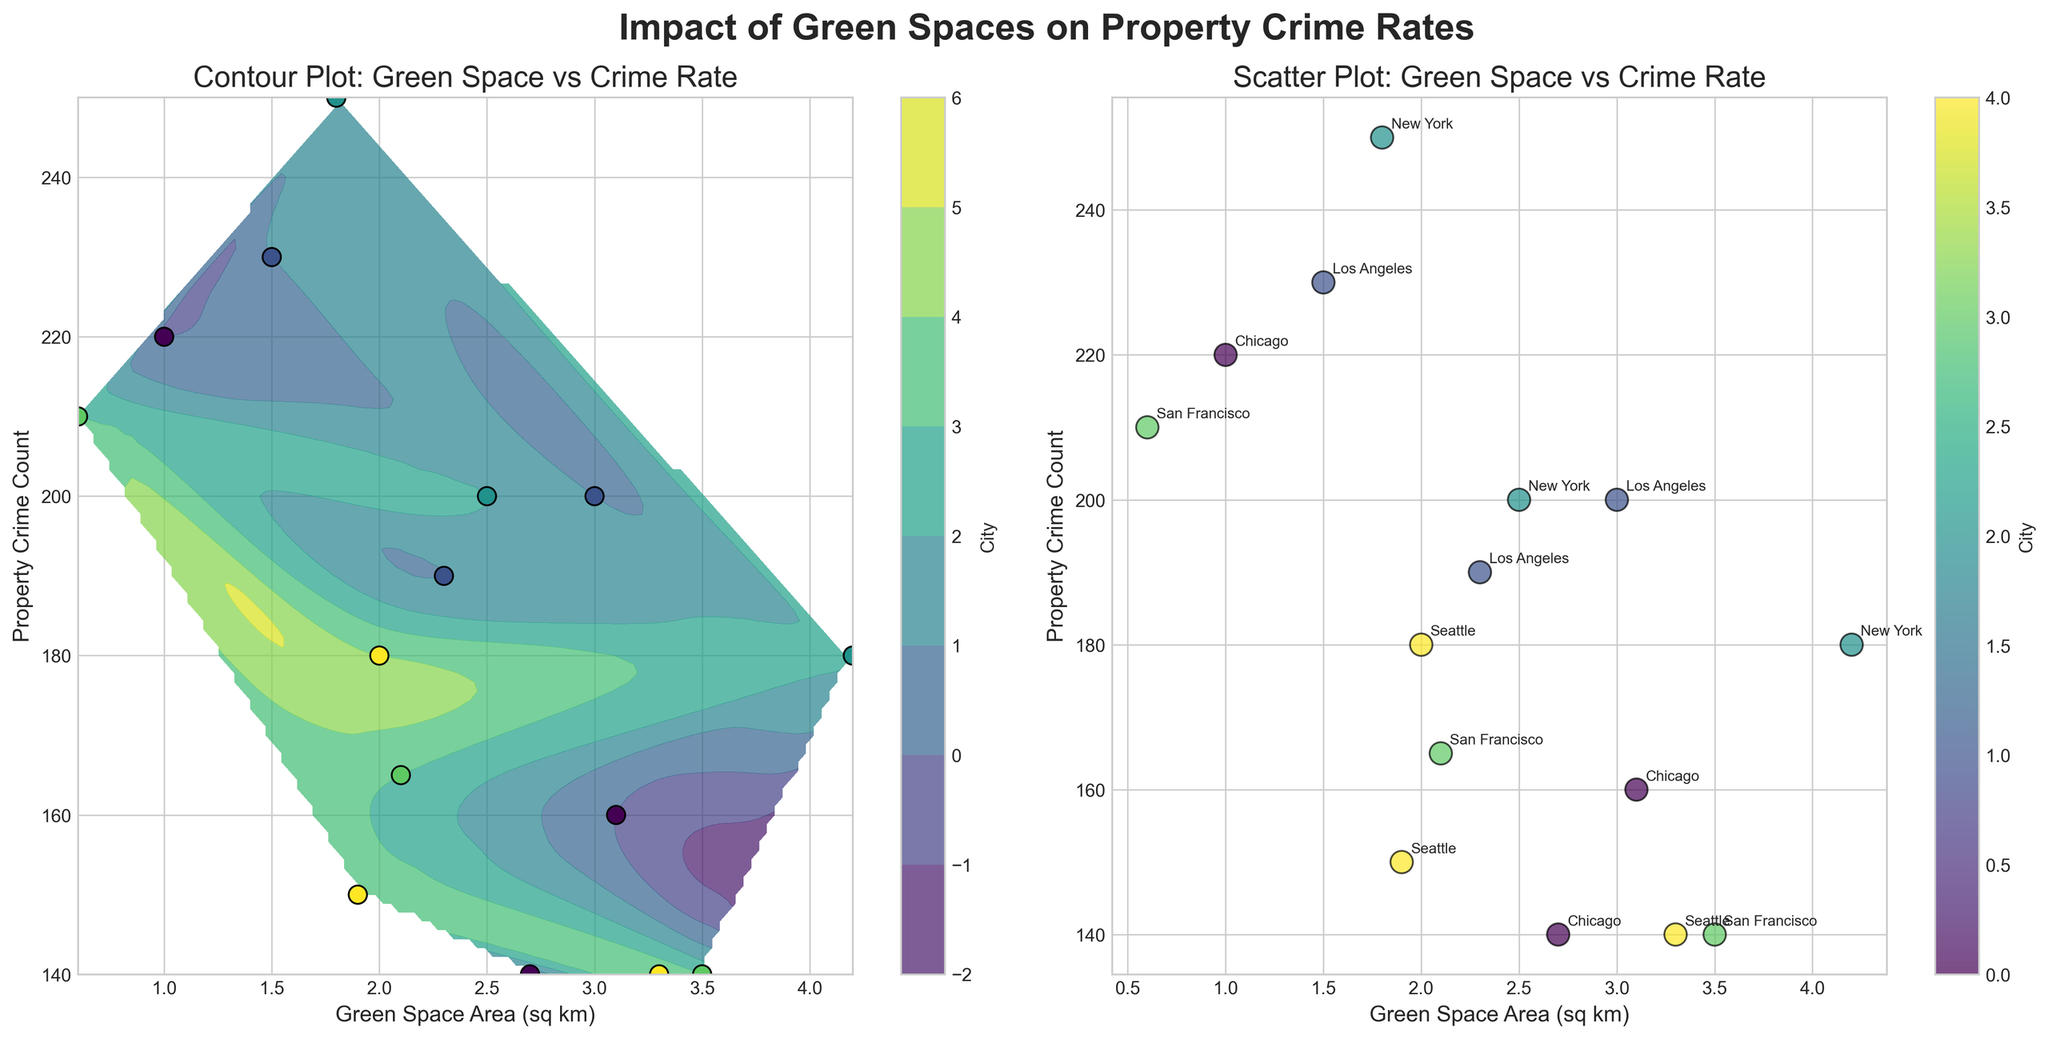What is the title of the figure? The title of the figure is shown at the top of the figure in bold text. It gives an overall description of the visualized data.
Answer: Impact of Green Spaces on Property Crime Rates Which city has the highest property crime count in the scatter plot? By examining the scatter plot, find the data point with the highest position on the Property Crime Count axis.
Answer: New York (Manhattan) What is the range of Green Space Area (sq km) shown on the x-axis? Look at the start and end points of the x-axis in both subplots to determine the range of Green Space Area.
Answer: 0.6 to 4.2 sq km How many neighborhoods have property crime counts below 150? Count the number of data points below the 150 mark on the Property Crime Count axis in both subplots.
Answer: 4 neighborhoods Which city appears to have the least green space area yet high property crime rate? Identify the city with the lowest values on the Green Space Area axis and high values on the Property Crime Count axis in the scatter plot.
Answer: San Francisco (Chinatown) Are there more data points in the lower or higher ranges of green space areas? Compare the density of data points on the x-axis across the scatter plot to see whether they are more frequent in the lower or higher ranges.
Answer: Lower ranges In which subplot are the city names annotated on the data points? Look at both subplots and identify which one has text labels next to the data points, indicating the names of the cities.
Answer: Scatter Plot How do property crime counts generally change as green space area increases? Examine the overall trend of data points in the scatter plot to infer the relationship between green space area and crime counts.
Answer: Generally decreases What colors are used to represent cities in the contour plot? Observe the colorbar next to the contour plot to determine the range of colors used to represent different cities.
Answer: Shades of green and purple What is the impact of green space on property crime rates in Chicago neighborhoods? Identify the data points representing Chicago neighborhoods in both subplots and analyze the trend between green space area and property crime counts.
Answer: Generally lower crime rates with more green space 